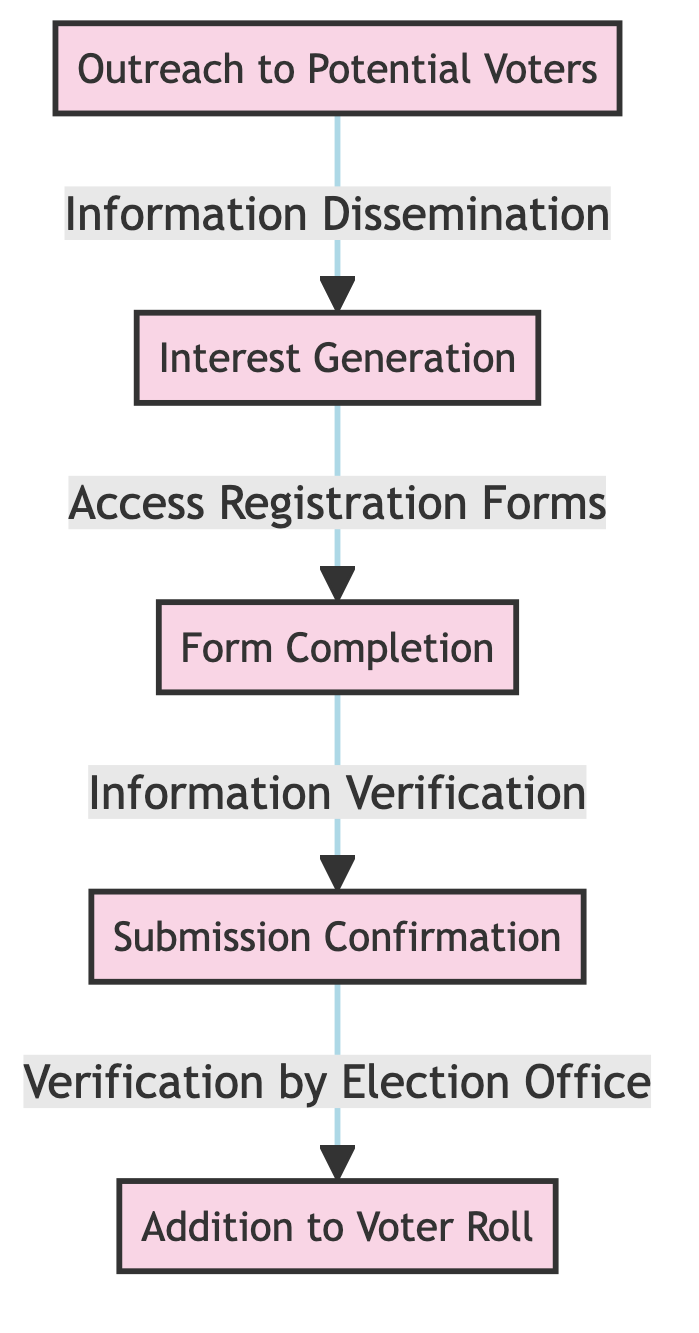What is the first step in the voter registration pathway? The diagram starts with the node labeled "Outreach to Potential Voters," indicating that this is the initial step in the pathway.
Answer: Outreach to Potential Voters How many nodes are present in the diagram? By counting the distinct labeled nodes in the diagram, we find a total of five nodes: Outreach to Potential Voters, Interest Generation, Form Completion, Submission Confirmation, and Addition to Voter Roll.
Answer: 5 What action follows the completion of the form? In the diagram, the action that immediately follows "Form Completion" is "Information Verification." This describes the next step in the pathway.
Answer: Information Verification What leads to the addition of a voter to the voter roll? The diagram shows that "Verification by Election Office" is the step that leads to "Addition to Voter Roll," indicating that verification is necessary before a voter is added to the voter roll.
Answer: Verification by Election Office Which step comes after the interest generation? After "Interest Generation," the next step indicated in the diagram is "Access Registration Forms." This signifies that generating interest leads potential voters to obtain registration forms.
Answer: Access Registration Forms Which node represents the confirmation of submission? The node labeled "Submission Confirmation" in the diagram represents the confirmation that occurs after a form is completed. This signifies an important step in the validation process.
Answer: Submission Confirmation What is the relationship between Information Verification and Submission Confirmation? "Information Verification" follows "Submission Confirmation" in the flow of the diagram, indicating that verifying the provided information comes after the confirmation has been received for the submitted forms.
Answer: follows What step directly follows the addition of a voter to the voter roll? In the diagram, there are no further steps indicated after "Addition to Voter Roll," meaning this is the final step in the pathway for voter registration.
Answer: None What is the last stage in the voter registration process? The final stage, as depicted in the diagram, is the "Addition to Voter Roll," signifying the completion of the voter registration pathway.
Answer: Addition to Voter Roll 